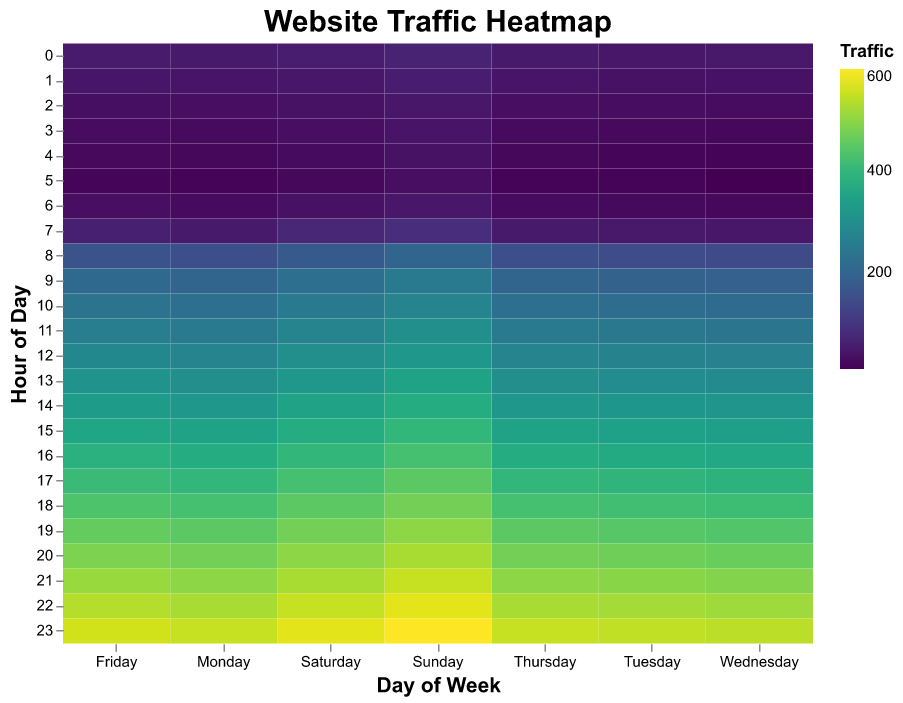what does the title of the heatmap say? The title of a heatmap is usually located at the top of the chart and describes the content of the figure. In this case, the title is "Website Traffic Heatmap."
Answer: Website Traffic Heatmap How is traffic represented in the heatmap? In a heatmap, traffic is often represented by color intensity. The values in the data are mapped to colors using a color scale. In this case, the 'viridis' scheme is used, where traffic increases with the intensity of color.
Answer: Color intensity Which hour of the day has the highest traffic on Sunday? To find the hour with the highest traffic, look at the column for Sunday and identify the row with the darkest color or highest value. The highest traffic value for Sunday is 600 at hour 23.
Answer: 23 What day has the lowest website traffic at 5 AM? To determine this, check the row corresponding to 5 AM across all days, then identify the lowest value. The lowest value at 5 AM is 10 on Wednesday.
Answer: Wednesday What's the average traffic at 1 PM on weekends (Saturday and Sunday)? To find the average, first get the traffic values for 1 PM on Saturday (325) and Sunday (350), then sum them and divide by 2. Calculation: (325 + 350) / 2 = 337.5
Answer: 337.5 Which day has the most consistent traffic throughout the day? To assess consistency, compare the variations in the color gradient for each day. A day where the colors change the least would indicate consistency. Monday appears to have the most consistent traffic, as the color gradient changes gradually without abrupt shifts.
Answer: Monday How does the traffic trend change from early morning (0 AM) to late evening (11 PM) on Fridays? To observe the trend, examine the Friday column from top to bottom. The trend shows a gradual increase in traffic as the color intensity becomes darker from early morning (52 at 0 AM) to late evening (560 at 11 PM).
Answer: Gradual increase On which day and hour can we observe the maximum website traffic? Look for the darkest and most intense color cell in the entire heatmap. The maximum website traffic of 600 occurs on Sunday at 11 PM.
Answer: Sunday at 11 PM Compare the website traffic at 10 AM for Monday and Wednesday. Which day has higher traffic? Compare the values at 10 AM for both Monday (225) and Wednesday (215). Monday has higher traffic.
Answer: Monday What's the total traffic for all days at 9 AM? To find the total, add up the traffic values at 9 AM for all days: 200 (Monday) + 195 (Tuesday) + 190 (Wednesday) + 200 (Thursday) + 210 (Friday) + 225 (Saturday) + 250 (Sunday). Calculation: 200 + 195 + 190 + 200 + 210 + 225 + 250 = 1470
Answer: 1470 